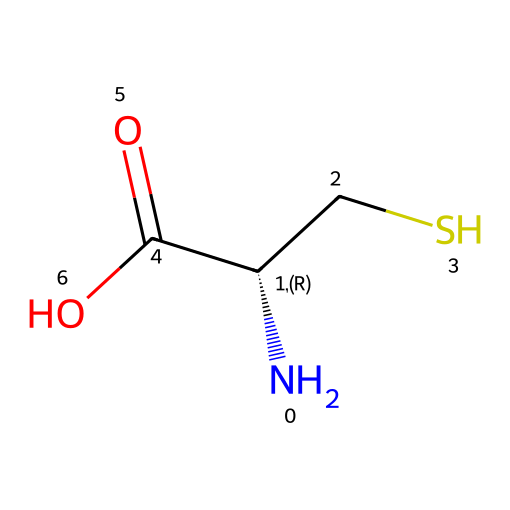How many sulfur atoms are present in the molecule? The SMILES representation includes "CS", indicating that there is one sulfur (S) atom attached to a carbon (C) atom.
Answer: one What is the total number of carbon atoms in this structure? Analyzing the SMILES, "N[C@@H](CS)C(=O)O" indicates there are two carbon atoms: one from "C" in "CS" and one from "C(=O)O".
Answer: two What functional groups are present in this amino acid? The structure includes an amine group (N-) and a carboxylic acid group (-C(=O)O), as seen in the "N" at the beginning and "C(=O)O" at the end.
Answer: amine and carboxylic acid How many hydrogen atoms can be inferred in this molecule's structure? From the nitrogen (N) and two carbon (C) atoms, with the presence of the sulfur (S) and carboxylic acid, we can deduce there are four hydrogen atoms overall in the molecule based on typical valences.
Answer: four What type of amino acid is represented by this structure? The presence of the sulfur atom in the structure indicates that this is a sulfur-containing amino acid, which classifies it specifically as cysteine.
Answer: cysteine Which feature of the molecule allows it to participate in oxidative reactions? The thiol (-SH) group from the sulfur atom is responsible for the oxidizing capacity, making the compound reactive in redox reactions.
Answer: thiol group 